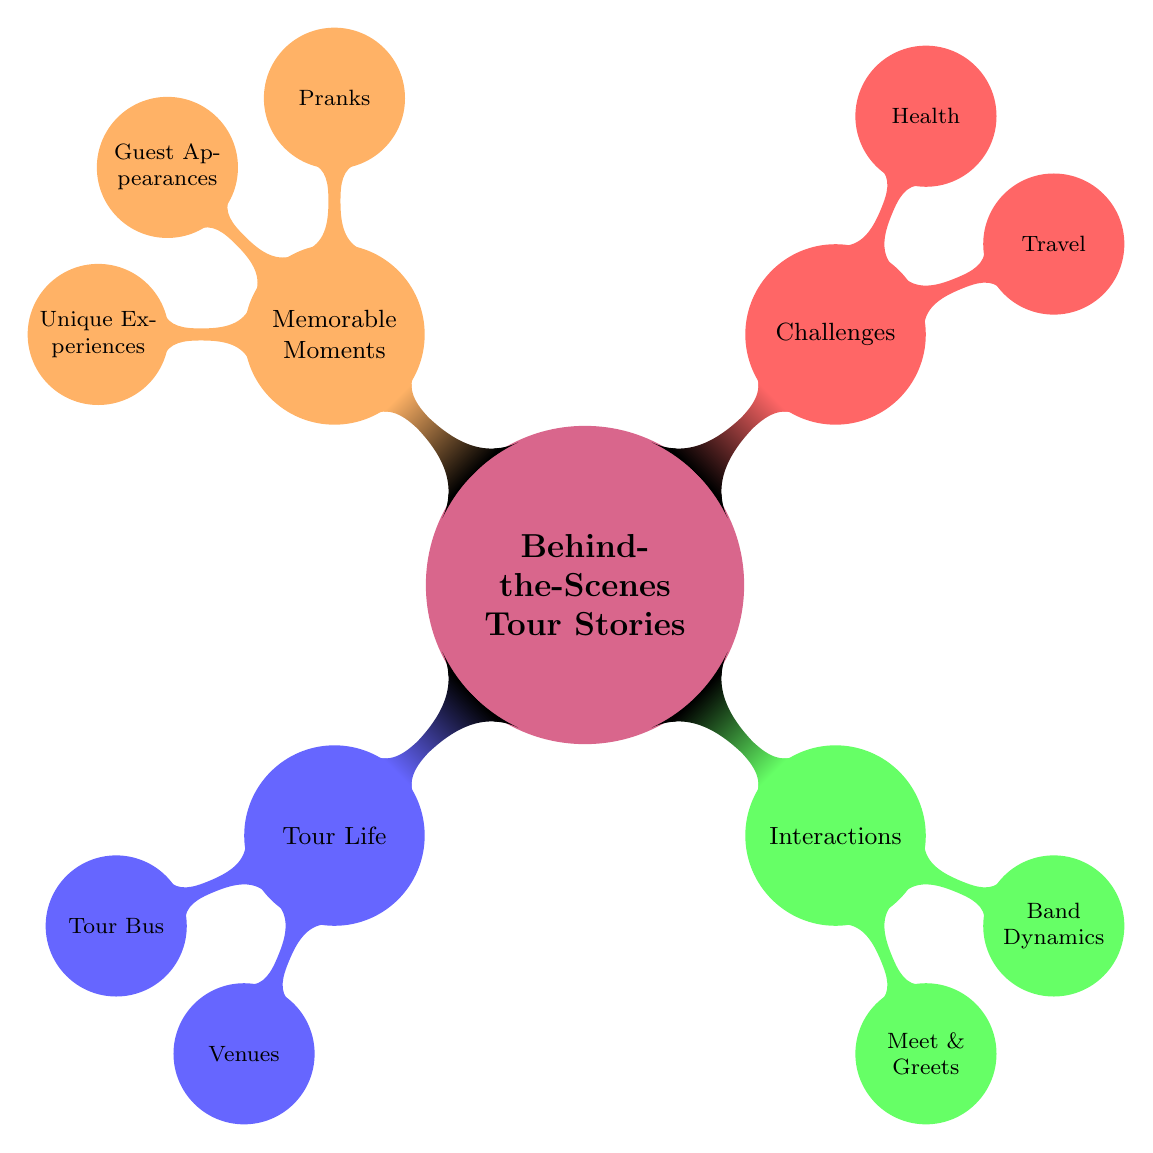What are the main categories in the mind map? The main categories in the mind map are "Tour Life," "Interactions," "Challenges," and "Memorable Moments." This can be determined by looking at the first level nodes that branch from the central concept.
Answer: Tour Life, Interactions, Challenges, Memorable Moments How many sub-nodes are under "Tour Life"? Under "Tour Life," there are two sub-nodes: "Tour Bus" and "Venues." This can be counted directly from the diagram, which shows these as the child nodes.
Answer: 2 What is one type of memorable moment mentioned? One type of memorable moment mentioned is "Pranks." This can be identified by locating the "Memorable Moments" category and then finding the specific examples listed under it.
Answer: Pranks Which category contains "Delayed Flights"? "Delayed Flights" is found under the "Challenges" category, specifically within the "Travel" sub-node. This requires tracing the branch from "Challenges" to "Travel" and identifying the listed items.
Answer: Challenges What are the three main aspects under "Interactions"? The three main aspects under "Interactions" are "Meet & Greets," "Band Dynamics," and "Support Team." To answer this, one needs to review the child nodes of "Interactions" and list them.
Answer: Meet & Greets, Band Dynamics, Support Team How many types of unique experiences are listed? There is one type of unique experience listed: "Local Foods," "Cultural Traditions," which counts as two total items within the "Unique Experiences" node under "Memorable Moments." By checking the children of this node, the number of items can be counted.
Answer: 2 What type of stories are included in "Meet & Greets"? "Meet & Greets" includes "Fan Stories," "Autograph Sessions," and "Photo Ops." This answer is derived from the child nodes of "Meet & Greets," which list these elements explicitly.
Answer: Fan Stories, Autograph Sessions, Photo Ops Which aspect of health is mentioned in the diagram? The aspect of health mentioned is "Illnesses." This can be deduced by examining the "Health" sub-node under "Challenges," which specifies these items.
Answer: Illnesses What is the relationship between "Band Member Roles" and "Band Dynamics"? "Band Member Roles" is a specific sub-topic discussed within the overarching topic of "Band Dynamics," indicating a close relationship whereby understanding roles contributes to dynamics. This requires analyzing the nested structure of the nodes.
Answer: Sub-topic relationship 